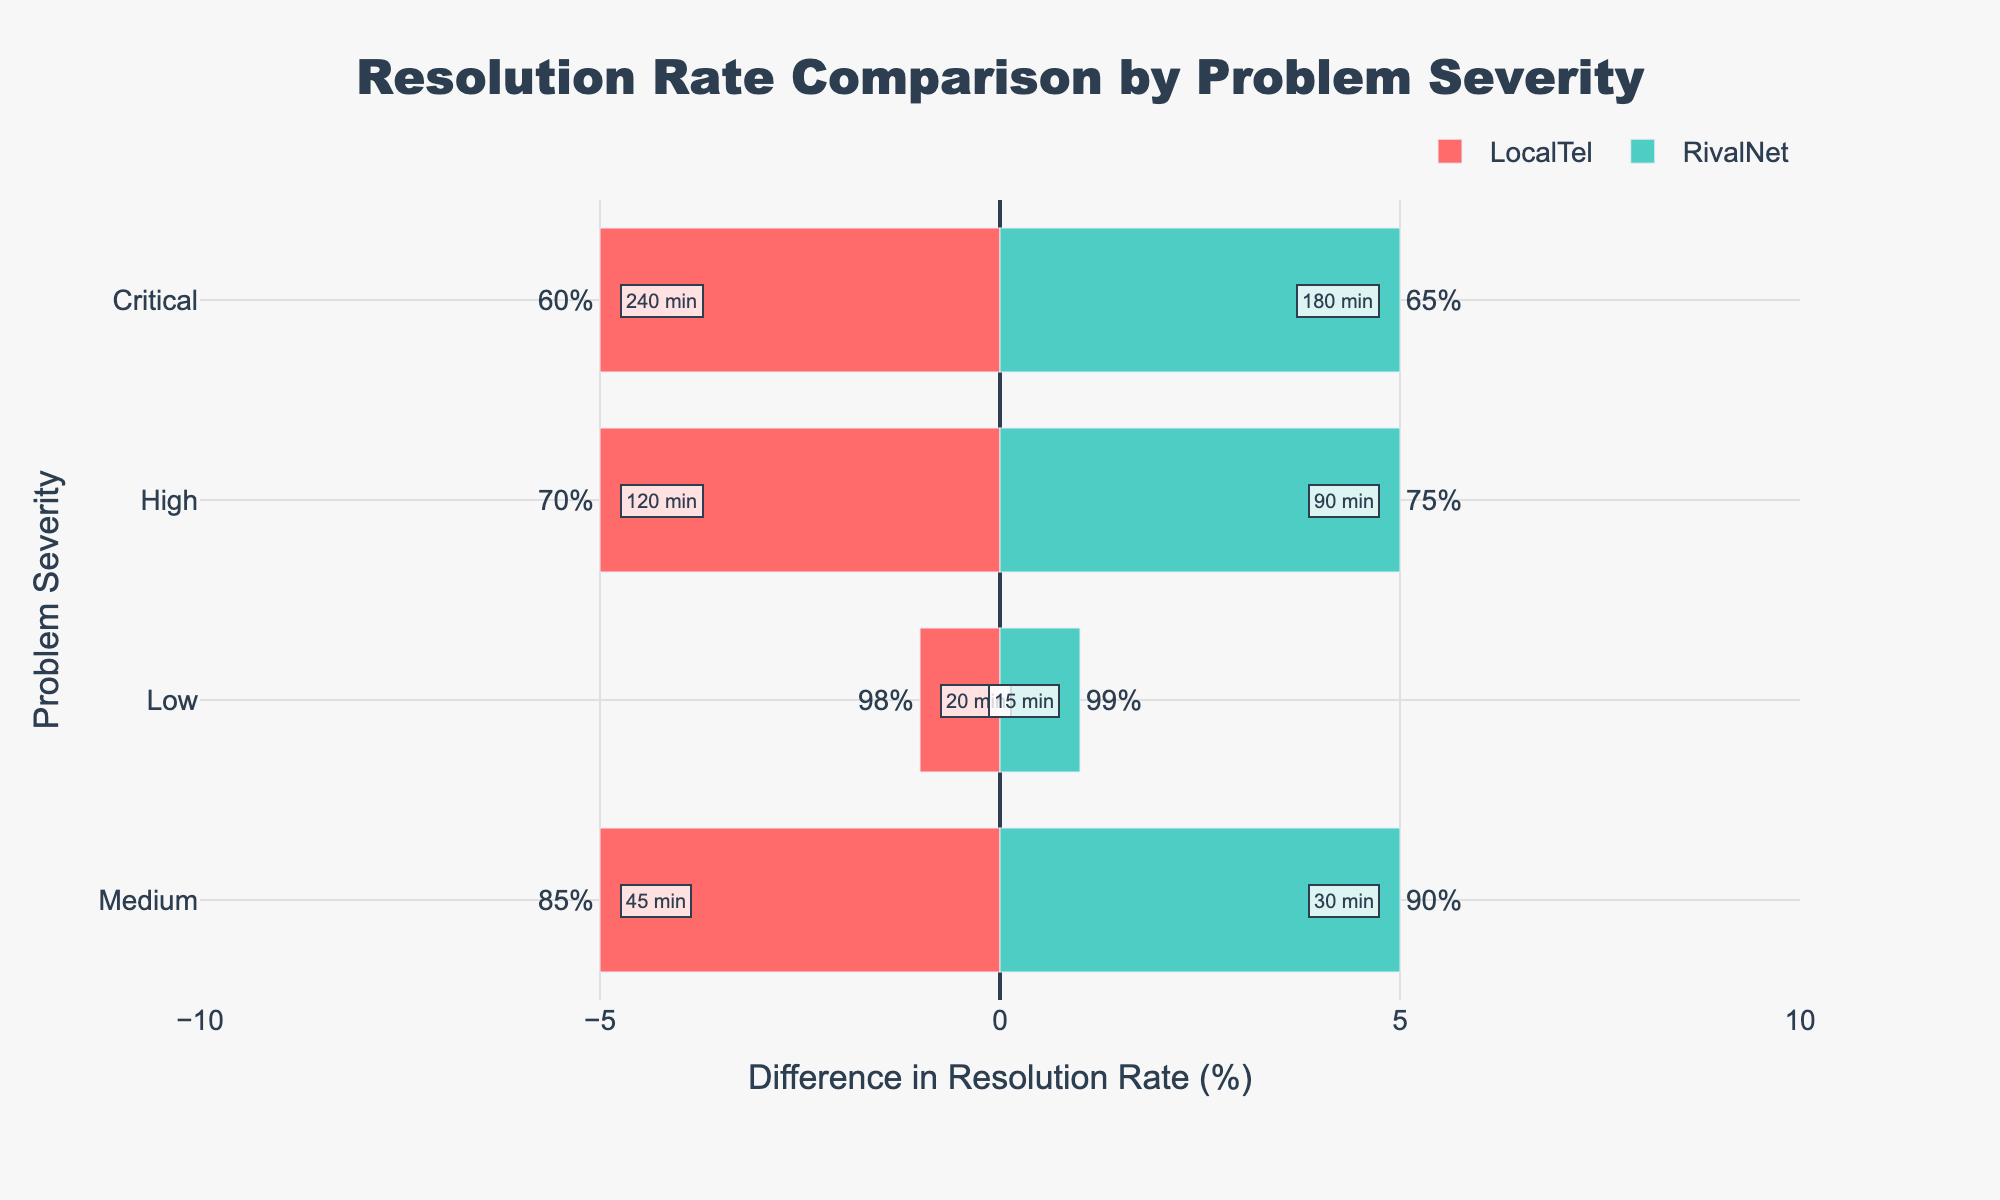What's the difference in resolution rate for "Critical" problems between LocalTel and RivalNet? First, identify the resolution rates for "Critical" problems: LocalTel has 60% and RivalNet has 65%. Subtract LocalTel's rate from RivalNet's rate: 65% - 60% = 5%.
Answer: 5% Which company has a shorter average response time for "High" severity problems? Compare the average response times for "High" severity problems: LocalTel has 120 minutes, and RivalNet has 90 minutes. RivalNet's response time is shorter.
Answer: RivalNet By how much does RivalNet outperform LocalTel in terms of resolution rate for "Medium" severity problems? Identify the resolution rates for "Medium" severity problems: LocalTel has 85% and RivalNet has 90%. Subtract LocalTel's rate from RivalNet's rate: 90% - 85% = 5%.
Answer: 5% Which company has the highest resolution rate for "Low" severity problems? Compare the resolution rates for "Low" severity problems: LocalTel has 98%, and RivalNet has 99%. RivalNet has the higher resolution rate.
Answer: RivalNet What is the average response time for "Low" severity problems across both companies? Add the response times for "Low" severity: 20 minutes (LocalTel) + 15 minutes (RivalNet) = 35 minutes. Divide by 2 to find the average: 35/2 = 17.5 minutes.
Answer: 17.5 minutes How does the resolution rate for "Critical" problems at LocalTel compare to "Medium" problems at RivalNet? The resolution rate for "Critical" problems at LocalTel is 60%, while the resolution rate for "Medium" problems at RivalNet is 90%. Subtract LocalTel's rate from RivalNet's rate: 90% - 60% = 30%.
Answer: 30% Which severity level shows the largest difference in response times between LocalTel and RivalNet? Calculate the difference in response times for each severity level:
- Low: 20 - 15 = 5 minutes
- Medium: 45 - 30 = 15 minutes
- High: 120 - 90 = 30 minutes
- Critical: 240 - 180 = 60 minutes
The largest difference is for "Critical" problems, which is 60 minutes.
Answer: Critical What is the total resolution rate for all severity levels combined for RivalNet? Add the resolution rates for RivalNet across all severity levels: 99% (Low) + 90% (Medium) + 75% (High) + 65% (Critical) = 329%.
Answer: 329% Which severity level has the smallest difference in resolution rate between the two companies? Calculate the difference in resolution rates for each severity level:
- Low: 99% - 98% = 1%
- Medium: 90% - 85% = 5%
- High: 75% - 70% = 5%
- Critical: 65% - 60% = 5%
The smallest difference is for "Low" problems, which is 1%.
Answer: Low 